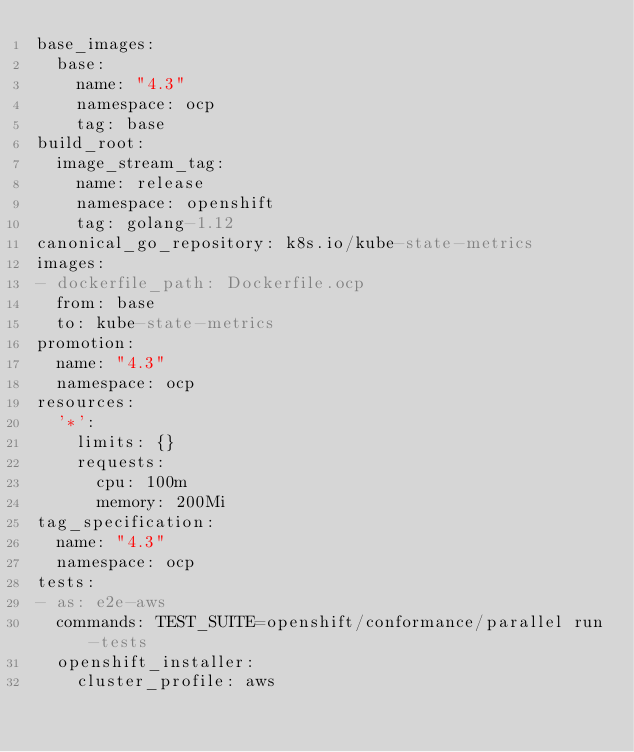Convert code to text. <code><loc_0><loc_0><loc_500><loc_500><_YAML_>base_images:
  base:
    name: "4.3"
    namespace: ocp
    tag: base
build_root:
  image_stream_tag:
    name: release
    namespace: openshift
    tag: golang-1.12
canonical_go_repository: k8s.io/kube-state-metrics
images:
- dockerfile_path: Dockerfile.ocp
  from: base
  to: kube-state-metrics
promotion:
  name: "4.3"
  namespace: ocp
resources:
  '*':
    limits: {}
    requests:
      cpu: 100m
      memory: 200Mi
tag_specification:
  name: "4.3"
  namespace: ocp
tests:
- as: e2e-aws
  commands: TEST_SUITE=openshift/conformance/parallel run-tests
  openshift_installer:
    cluster_profile: aws
</code> 